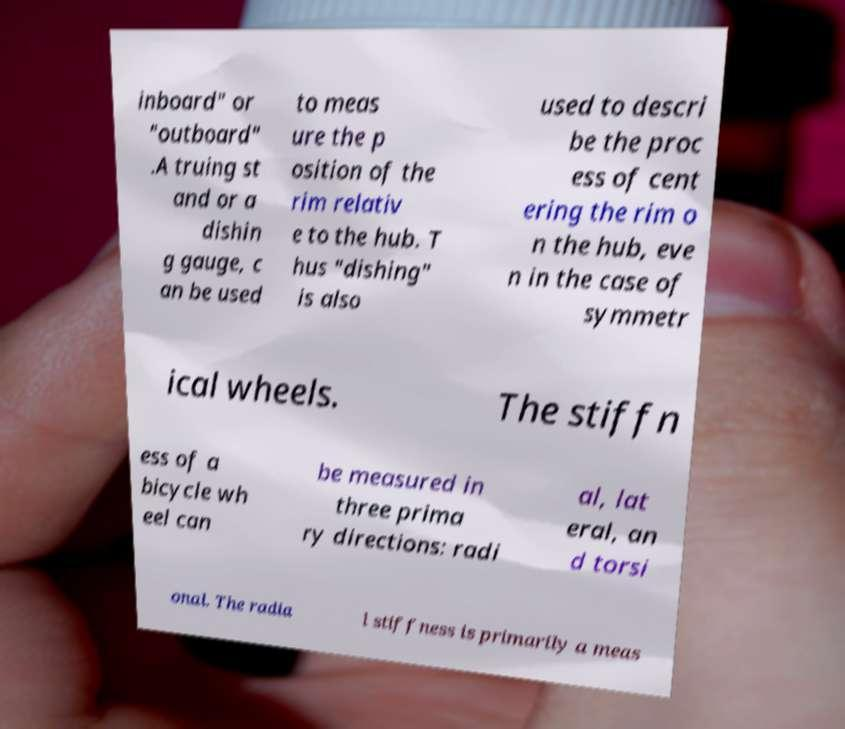There's text embedded in this image that I need extracted. Can you transcribe it verbatim? inboard" or "outboard" .A truing st and or a dishin g gauge, c an be used to meas ure the p osition of the rim relativ e to the hub. T hus "dishing" is also used to descri be the proc ess of cent ering the rim o n the hub, eve n in the case of symmetr ical wheels. The stiffn ess of a bicycle wh eel can be measured in three prima ry directions: radi al, lat eral, an d torsi onal. The radia l stiffness is primarily a meas 